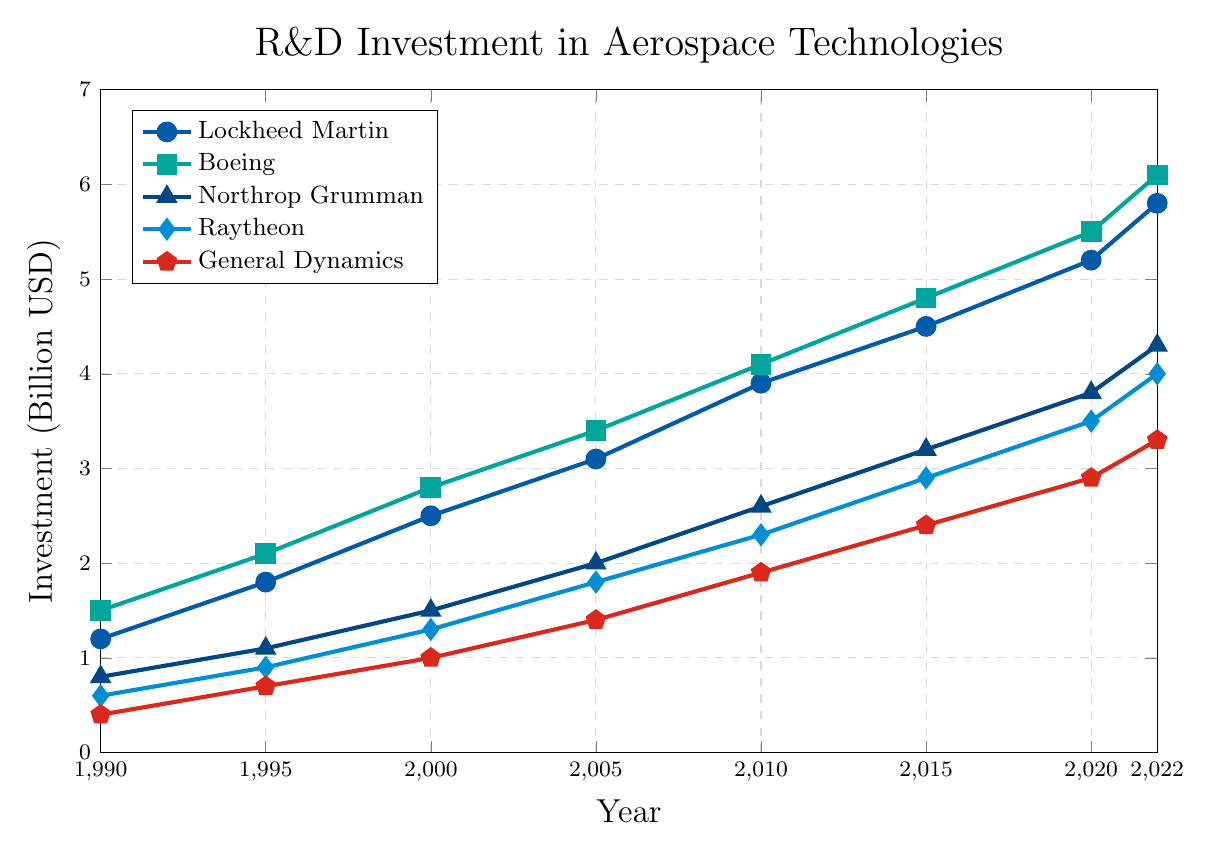What is the total investment by Lockheed Martin and Raytheon in 2022? The investment by Lockheed Martin in 2022 is 5.8 billion USD, and by Raytheon is 4.0 billion USD. The total is the sum of these two values: 5.8 + 4.0 = 9.8 billion USD.
Answer: 9.8 billion USD Which company had the highest R&D investment in 2010? The figure shows the R&D investments for 2010. Comparing the values, Boeing had the highest investment at 4.1 billion USD.
Answer: Boeing By how much did Northrop Grumman's investment increase from 1990 to 2022? Northrop Grumman's investment in 1990 was 0.8 billion USD and in 2022 it was 4.3 billion USD. The increase is calculated by subtracting the 1990 value from the 2022 value: 4.3 - 0.8 = 3.5 billion USD.
Answer: 3.5 billion USD Which company shows the most consistent growth in R&D investment over the years? To identify the most consistent growth, we observe the slopes of the lines for each company. General Dynamics shows a steady and consistent increase without large fluctuations from 1990 to 2022.
Answer: General Dynamics What is the approximate average annual growth rate of Boeing's R&D investment from 1990 to 2022? The initial investment in 1990 was 1.5 billion USD and the final investment in 2022 was 6.1 billion USD. The number of years is 2022 - 1990 = 32 years. The average annual growth rate is approximately (Final Value - Initial Value) / Number of Years = (6.1 - 1.5) / 32 = 4.6 / 32 ≈ 0.144 billion USD per year.
Answer: 0.144 billion USD per year What is the difference between Raytheon's and Northrop Grumman's R&D investment in 2020? In 2020, Raytheon's investment was 3.5 billion USD, and Northrop Grumman's was 3.8 billion USD. The difference is calculated as 3.8 - 3.5 = 0.3 billion USD.
Answer: 0.3 billion USD Between which two consecutive years did Lockheed Martin's investment increase the most? By observing the growth between consecutive points for Lockheed Martin, the largest increase is between 2015 and 2020, where the investment increased from 4.5 billion USD to 5.2 billion USD. The increase is 5.2 - 4.5 = 0.7 billion USD.
Answer: Between 2015 and 2020 What is the overall trend for the R&D investments by these top defense contractors from 1990 to 2022? The overall trend for all five companies shows a consistent increase in R&D investments over the years from 1990 to 2022.
Answer: Consistent increase 